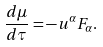Convert formula to latex. <formula><loc_0><loc_0><loc_500><loc_500>\frac { d \mu } { d \tau } = - u ^ { \alpha } F _ { \alpha } .</formula> 